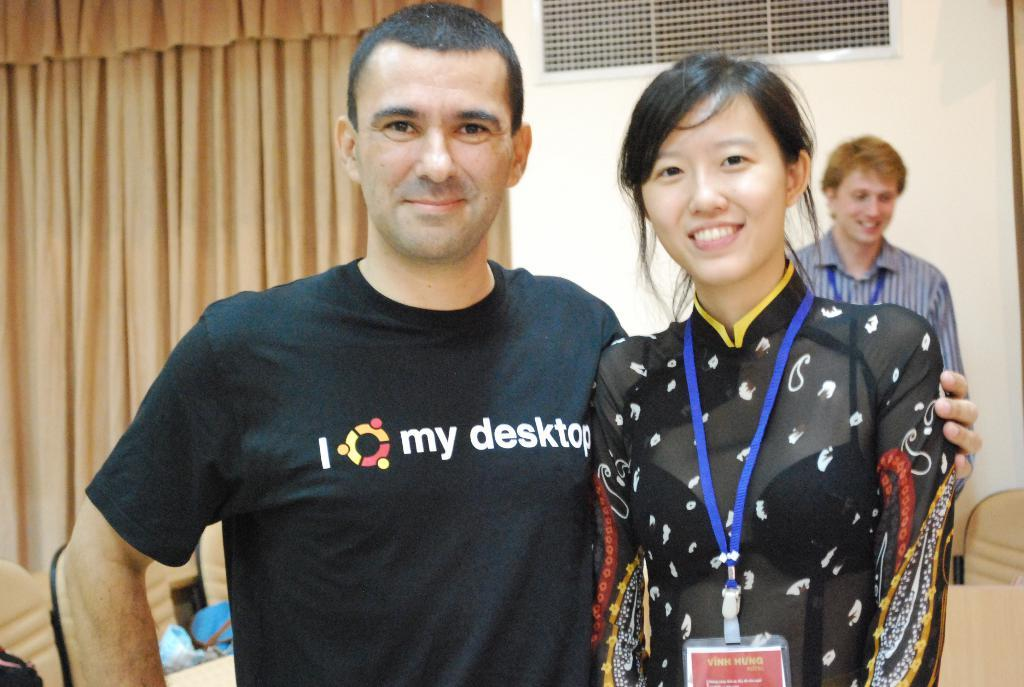<image>
Give a short and clear explanation of the subsequent image. Man wearing a shirt which says I my desktop posing with a woman. 